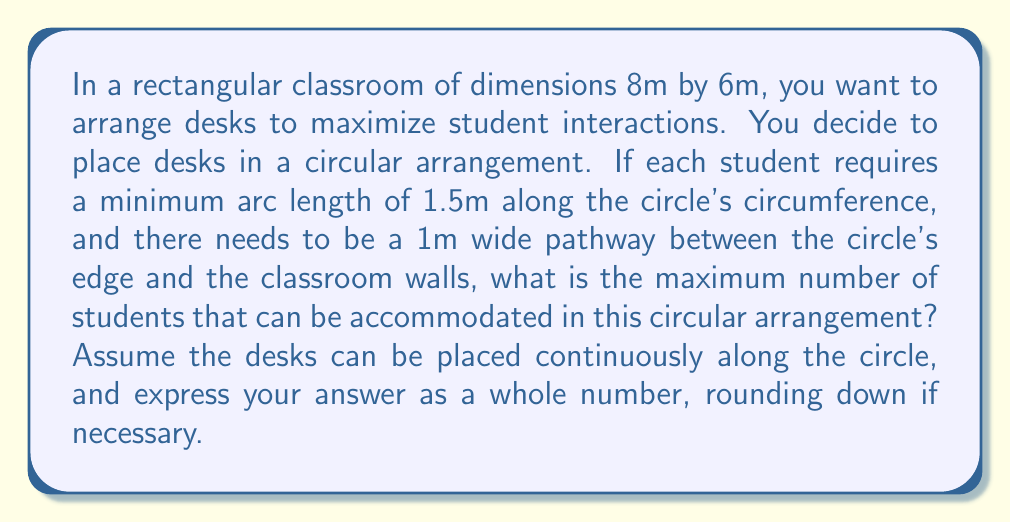Show me your answer to this math problem. To solve this problem, we need to follow these steps:

1) First, let's determine the maximum diameter of the circle that can fit in the classroom:
   - The room is 8m x 6m
   - We need a 1m pathway on all sides
   - So the maximum diameter is the smaller of (8-2) and (6-2), which is 4m

2) Now we can calculate the circumference of this circle:
   $$C = \pi d = \pi \cdot 4 = 4\pi \approx 12.57\text{m}$$

3) Each student requires 1.5m of arc length. To find the maximum number of students, we divide the total circumference by the required arc length per student:

   $$\text{Max Students} = \frac{\text{Circumference}}{\text{Arc Length per Student}} = \frac{4\pi}{1.5}$$

4) Calculating this:
   $$\frac{4\pi}{1.5} \approx 8.378$$

5) Since we can't have a fractional student, we round down to the nearest whole number.

Therefore, the maximum number of students that can be accommodated is 8.

This layout allows for maximum face-to-face interaction among students while maintaining necessary pathways for movement in the classroom.
Answer: 8 students 